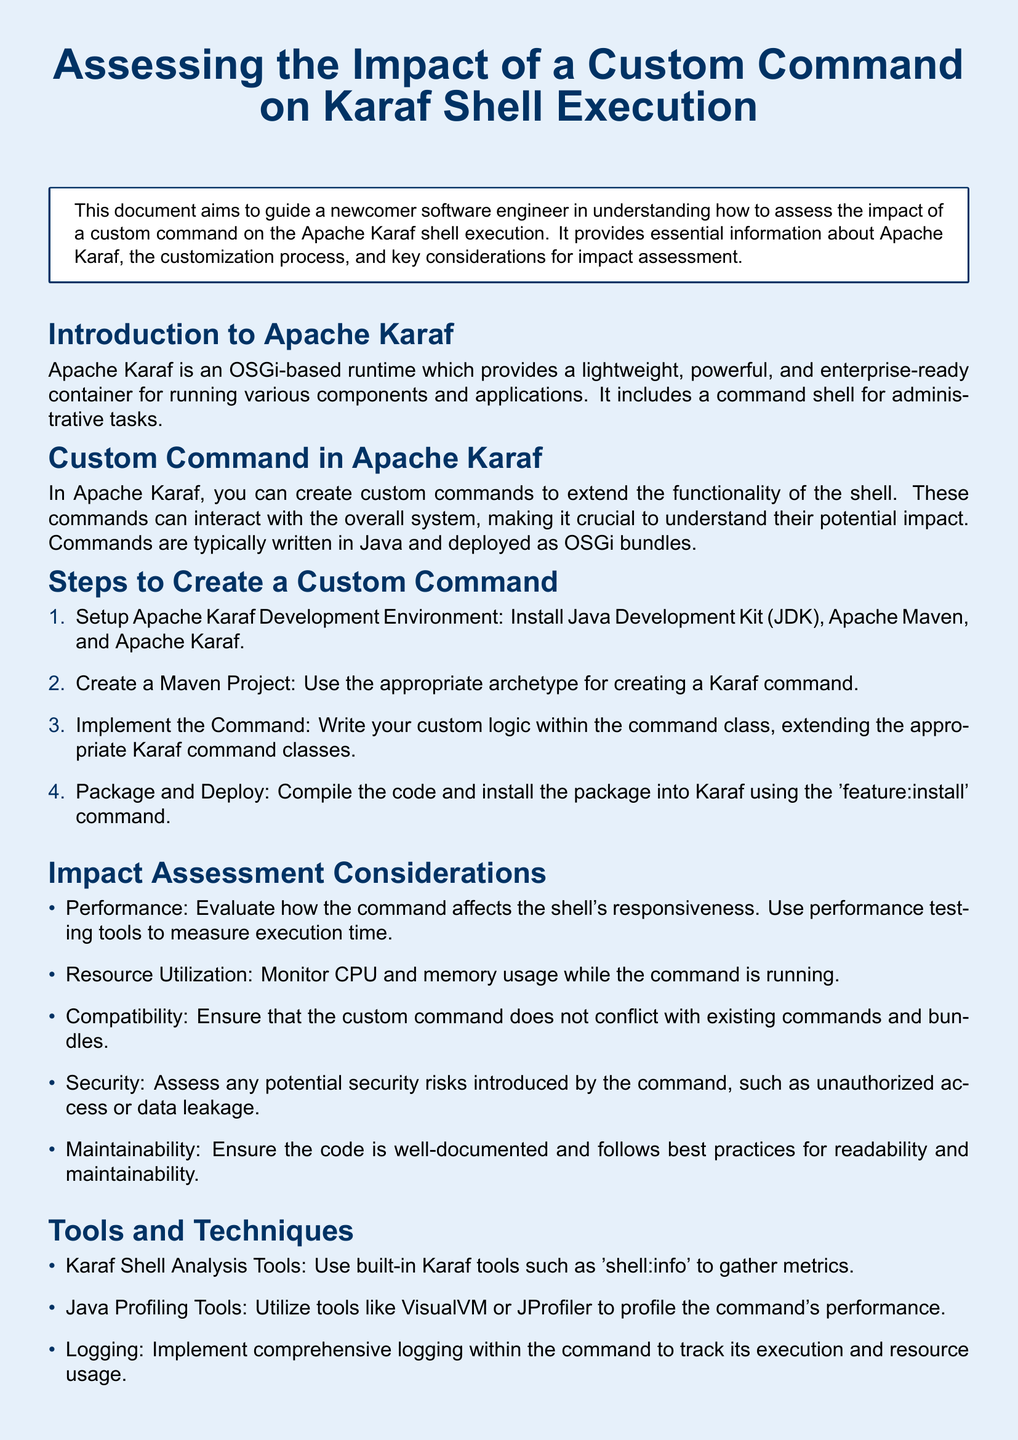What is the title of the document? The title of the document is presented at the top of the first page.
Answer: Assessing the Impact of a Custom Command on Karaf Shell Execution What is the first step to create a custom command? The document outlines a list of steps to create a custom command, with the first step specified clearly.
Answer: Setup Apache Karaf Development Environment Name a tool mentioned for profiling command performance. The document discusses tools available for analyzing and profiling performance, highlighting specific ones.
Answer: VisualVM What security aspect should be assessed for a custom command? The document includes a consideration regarding the safety of the custom command, pointing to specific risks.
Answer: Security risks How many impact assessment considerations are listed? The document presents a specific number of considerations under the impact assessment section.
Answer: Five What is mentioned as crucial for maintainability? The document discusses best practices in documentation and code quality that relate to maintainability.
Answer: Well-documented code What command is used for deploying the package in Karaf? The document specifies a command that is utilized for installing the package after compiling the code.
Answer: feature:install Which profiling tool is noted for logging execution? The impact assessment section mentions tools for logging and tracking execution details.
Answer: Logging 